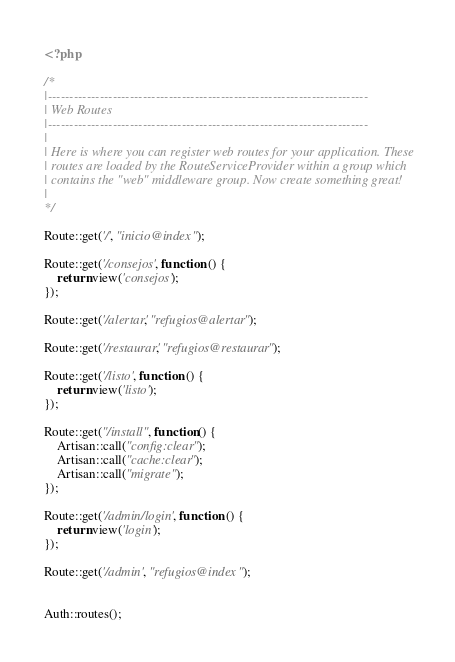<code> <loc_0><loc_0><loc_500><loc_500><_PHP_><?php

/*
|--------------------------------------------------------------------------
| Web Routes
|--------------------------------------------------------------------------
|
| Here is where you can register web routes for your application. These
| routes are loaded by the RouteServiceProvider within a group which
| contains the "web" middleware group. Now create something great!
|
*/

Route::get('/', "inicio@index");

Route::get('/consejos', function () {
    return view('consejos');
});

Route::get('/alertar', "refugios@alertar");

Route::get('/restaurar', "refugios@restaurar");

Route::get('/listo', function () {
    return view('listo');
});

Route::get("/install", function() {
	Artisan::call("config:clear");
	Artisan::call("cache:clear");
	Artisan::call("migrate");
});

Route::get('/admin/login', function () {
    return view('login');
});

Route::get('/admin', "refugios@index");


Auth::routes();</code> 